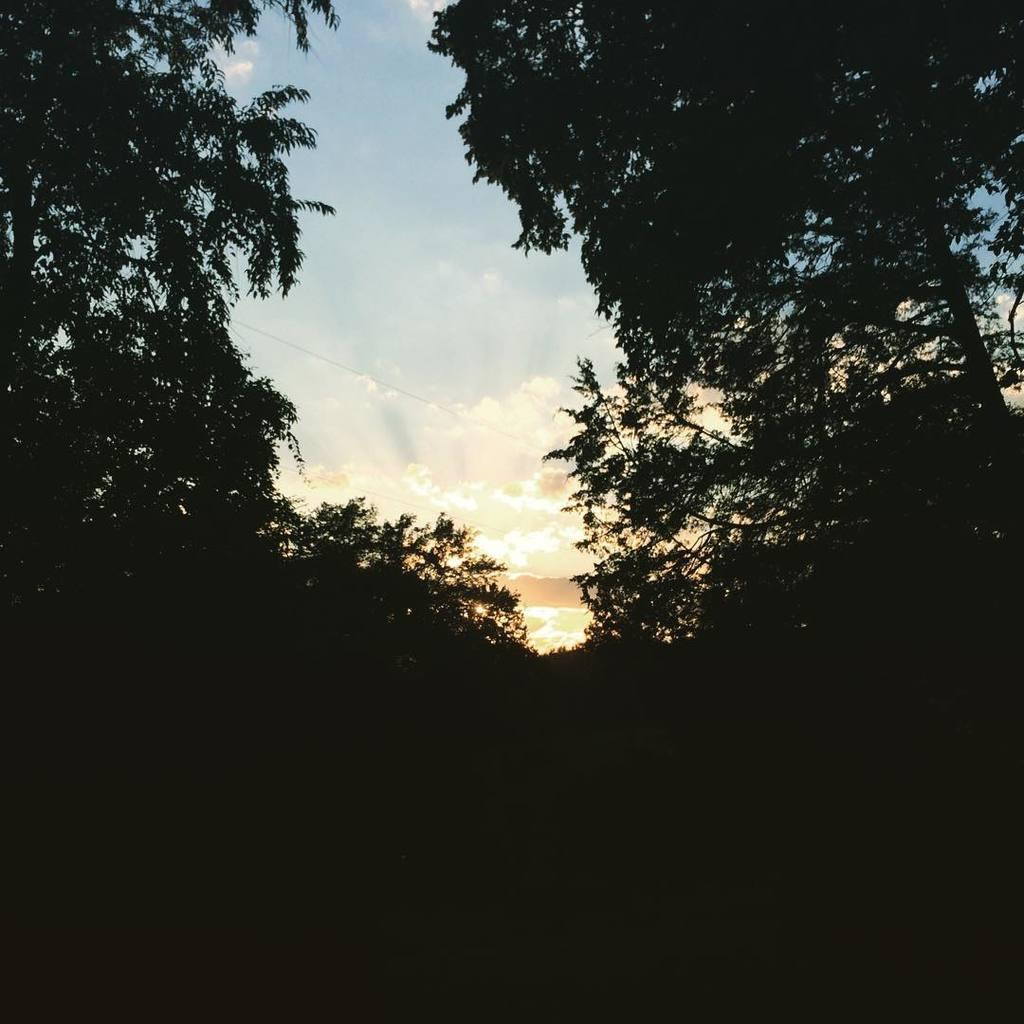What type of vegetation can be seen in the image? There are trees in the image. What can be observed in the sky in the image? There is a sunset visible in the background of the image. What type of stick can be seen in the image? There is no stick present in the image. What is the ice cream served on in the image? There is no ice cream or plate present in the image. 